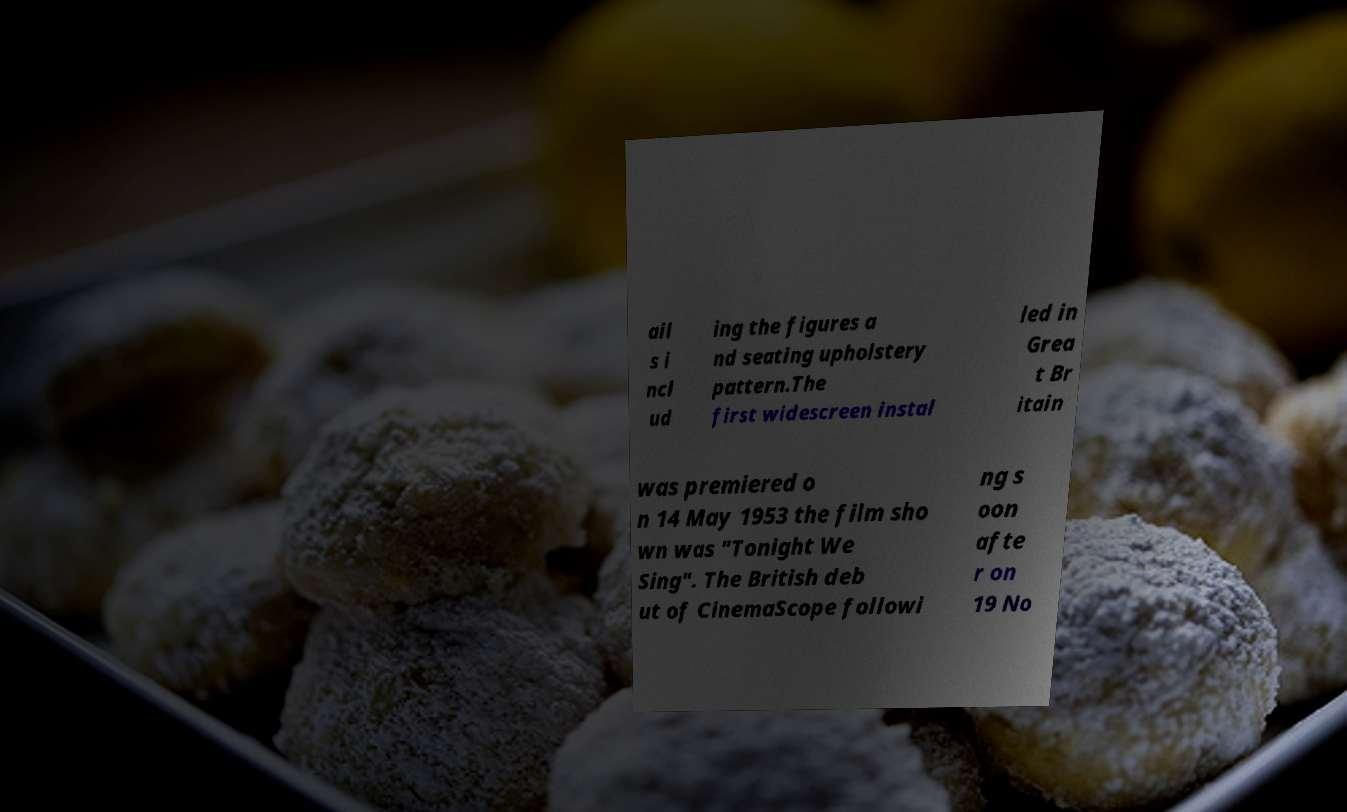Can you accurately transcribe the text from the provided image for me? ail s i ncl ud ing the figures a nd seating upholstery pattern.The first widescreen instal led in Grea t Br itain was premiered o n 14 May 1953 the film sho wn was "Tonight We Sing". The British deb ut of CinemaScope followi ng s oon afte r on 19 No 